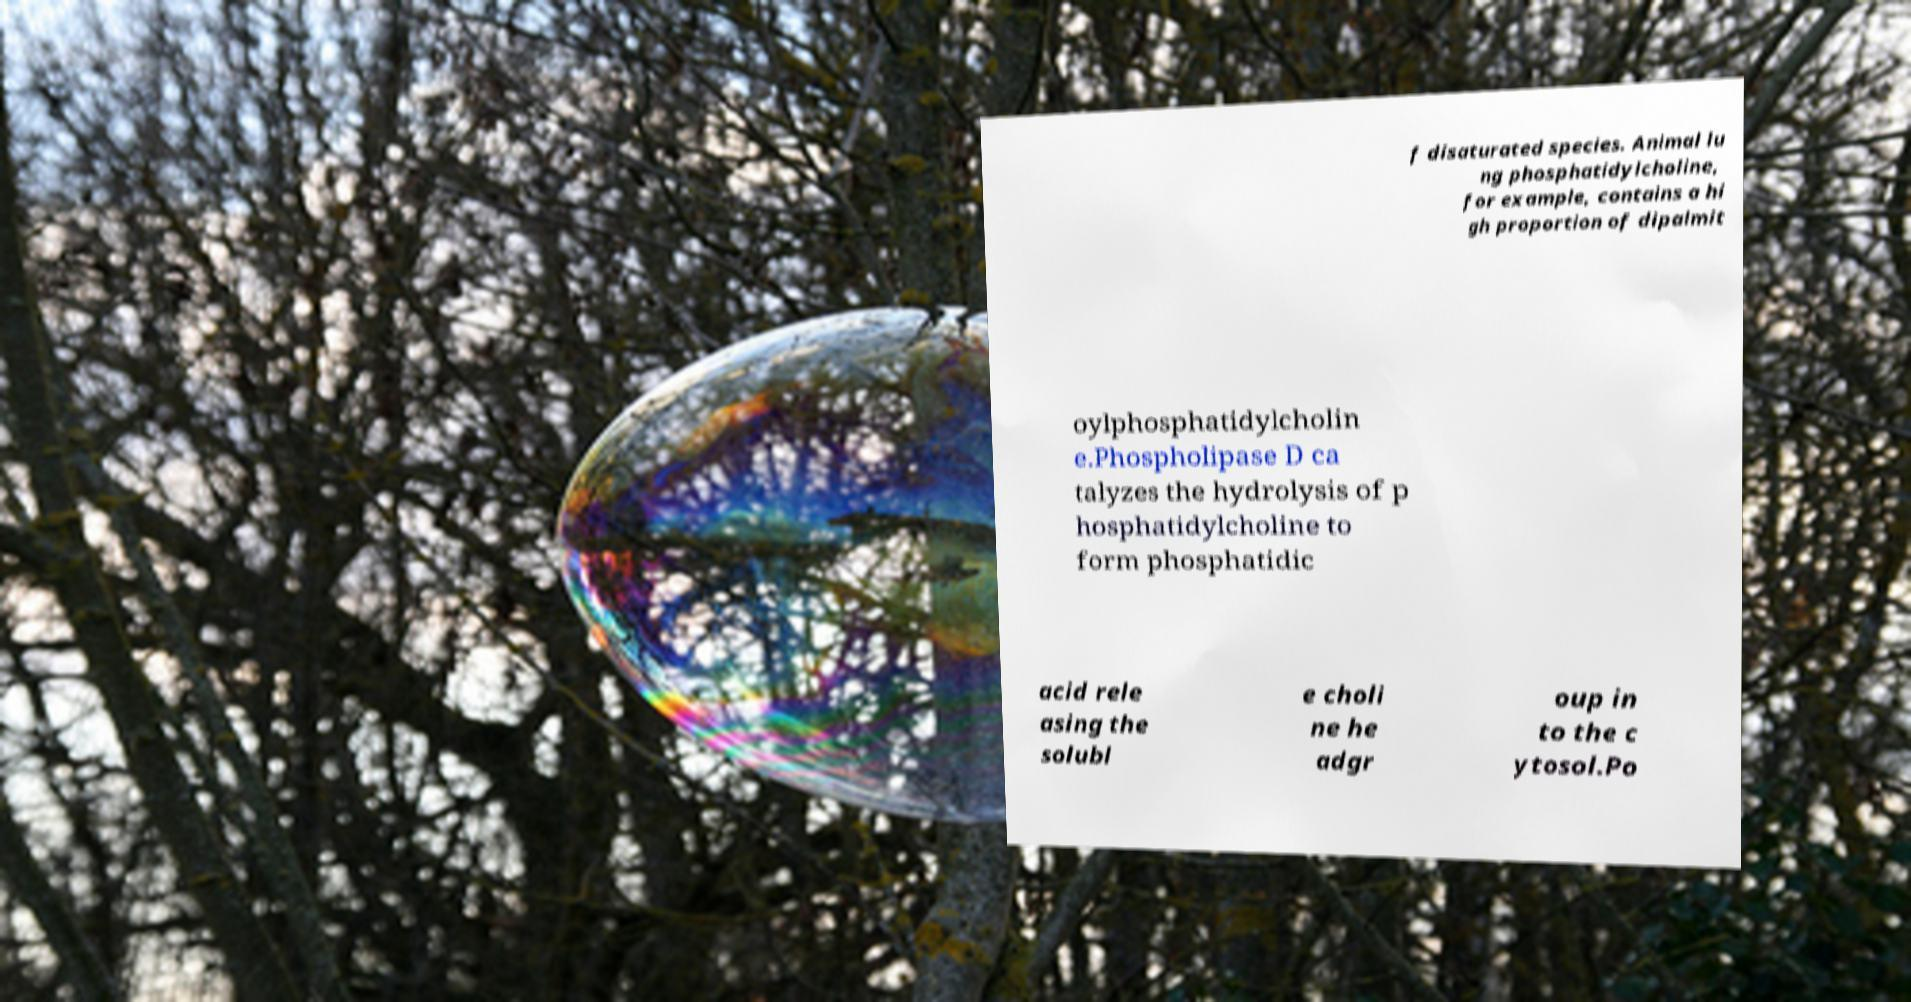What messages or text are displayed in this image? I need them in a readable, typed format. f disaturated species. Animal lu ng phosphatidylcholine, for example, contains a hi gh proportion of dipalmit oylphosphatidylcholin e.Phospholipase D ca talyzes the hydrolysis of p hosphatidylcholine to form phosphatidic acid rele asing the solubl e choli ne he adgr oup in to the c ytosol.Po 